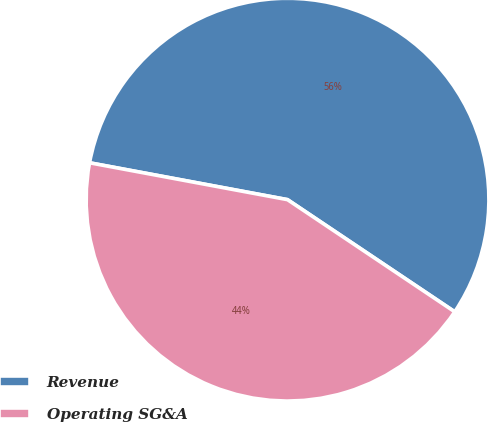Convert chart. <chart><loc_0><loc_0><loc_500><loc_500><pie_chart><fcel>Revenue<fcel>Operating SG&A<nl><fcel>56.47%<fcel>43.53%<nl></chart> 